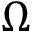Convert formula to latex. <formula><loc_0><loc_0><loc_500><loc_500>\Omega</formula> 